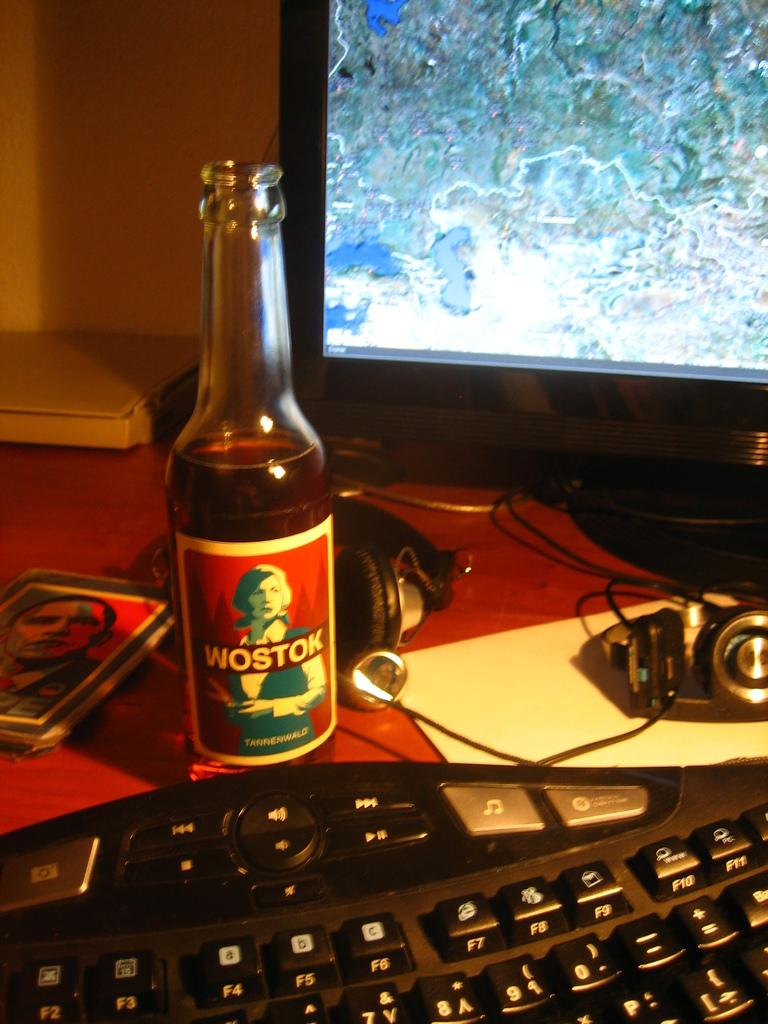Provide a one-sentence caption for the provided image. A bottle of Wostok I front of a computer keyboard. 